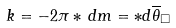Convert formula to latex. <formula><loc_0><loc_0><loc_500><loc_500>k = - 2 \pi * \, d m = * d \overline { \theta } _ { \Box }</formula> 